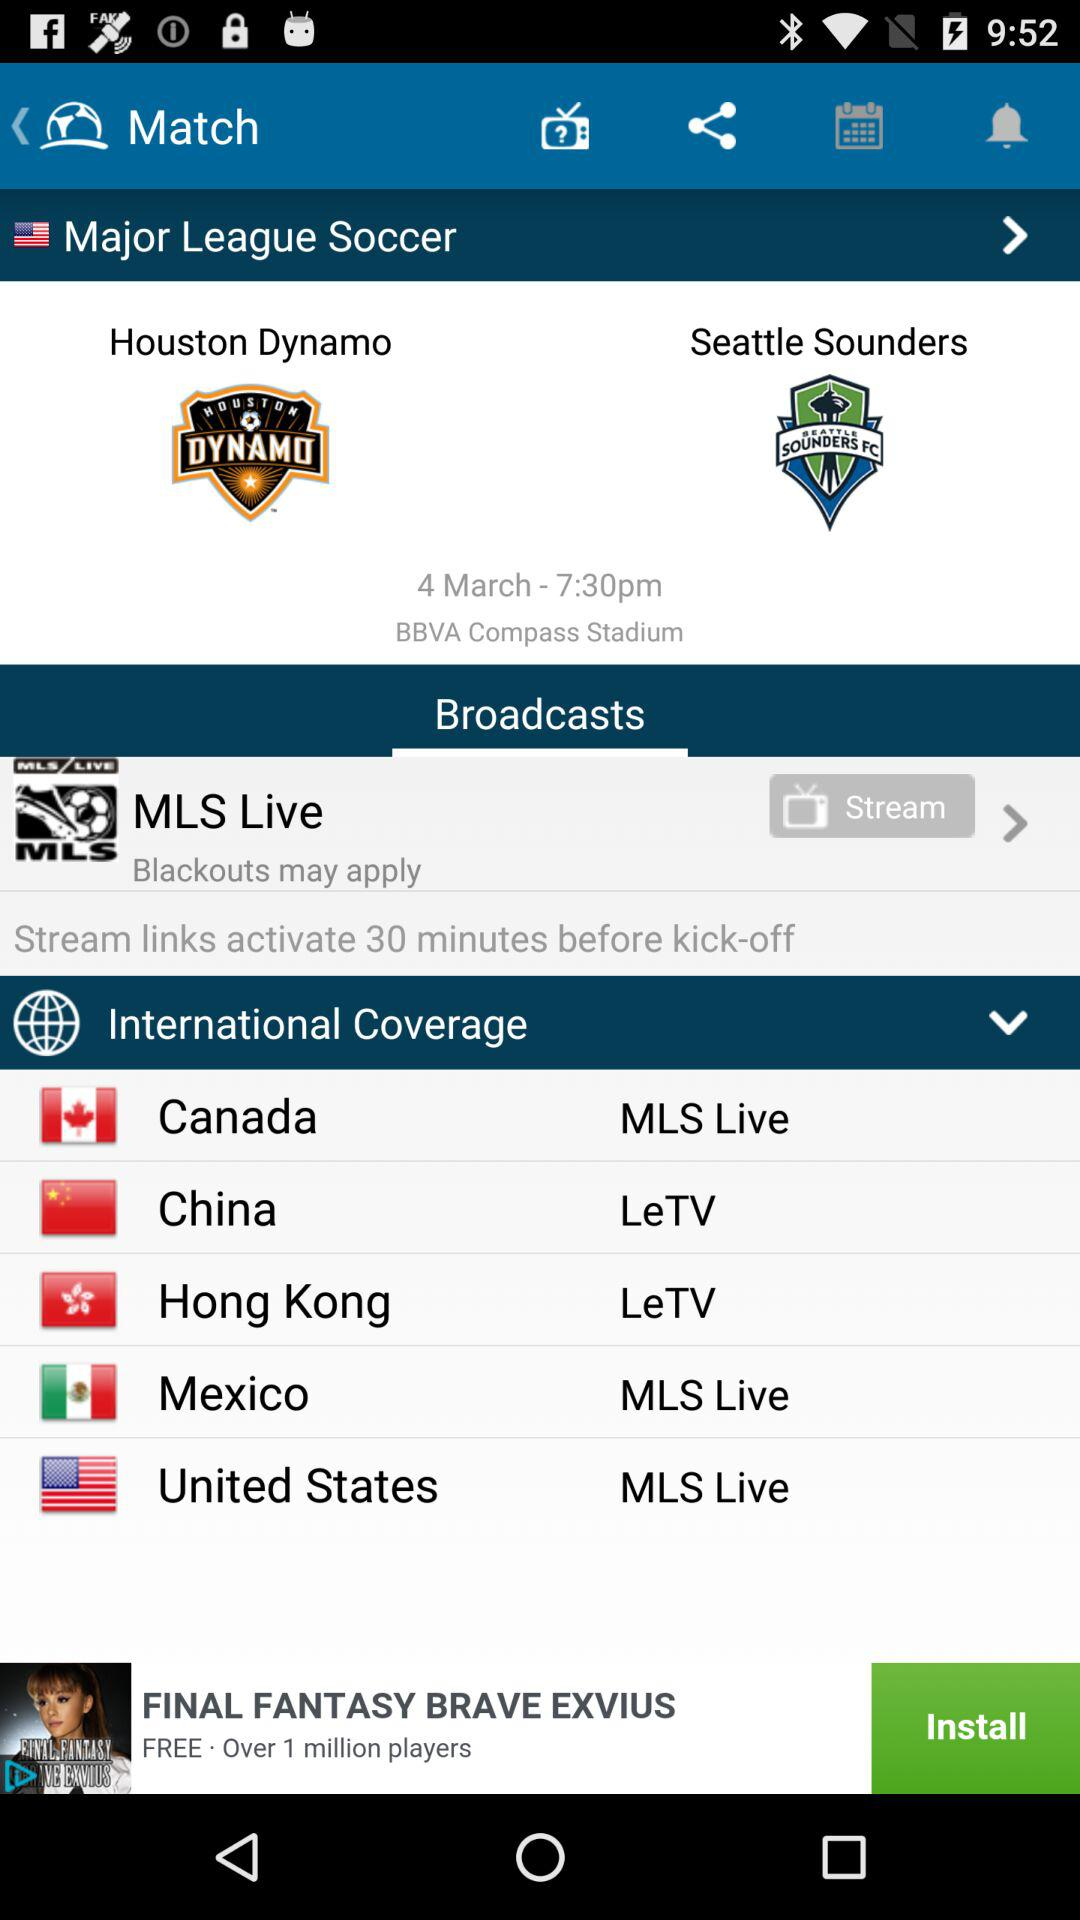What is the match number?
When the provided information is insufficient, respond with <no answer>. <no answer> 